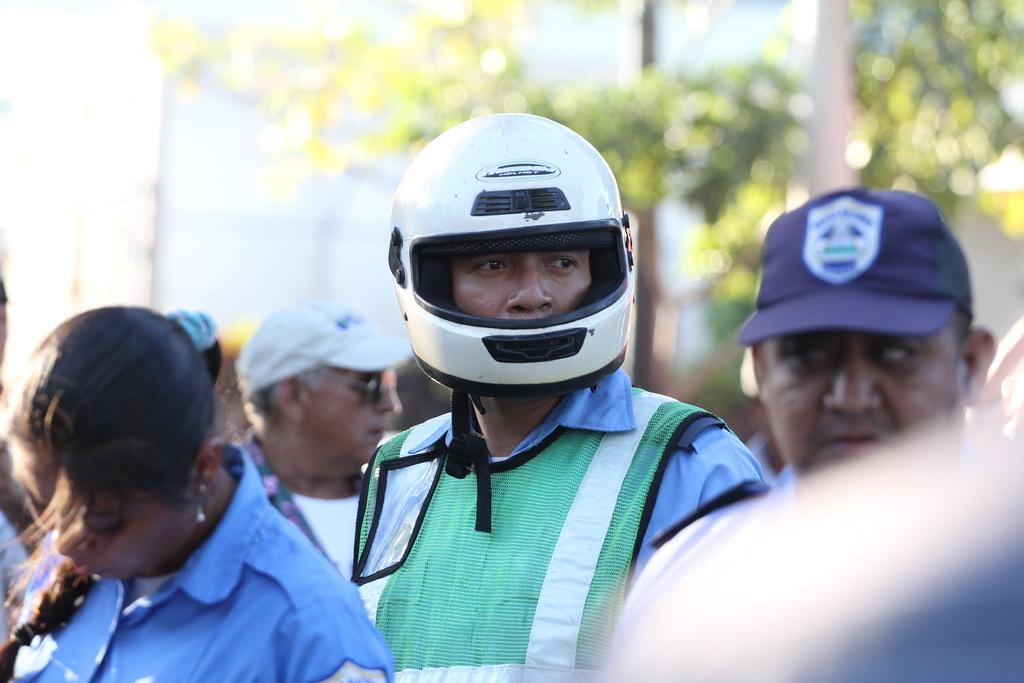How many people are present in the image? There are people in the image, but the exact number is not specified. Can you describe the distribution of people in the image? The people are scattered throughout the image. What can be seen in the background of the image? There are trees in the background of the image. What is the man in the image wearing? The man is wearing a helmet. Is the queen present on the island in the image? There is no mention of a queen or an island in the image, so it cannot be determined if the queen is present on an island. 